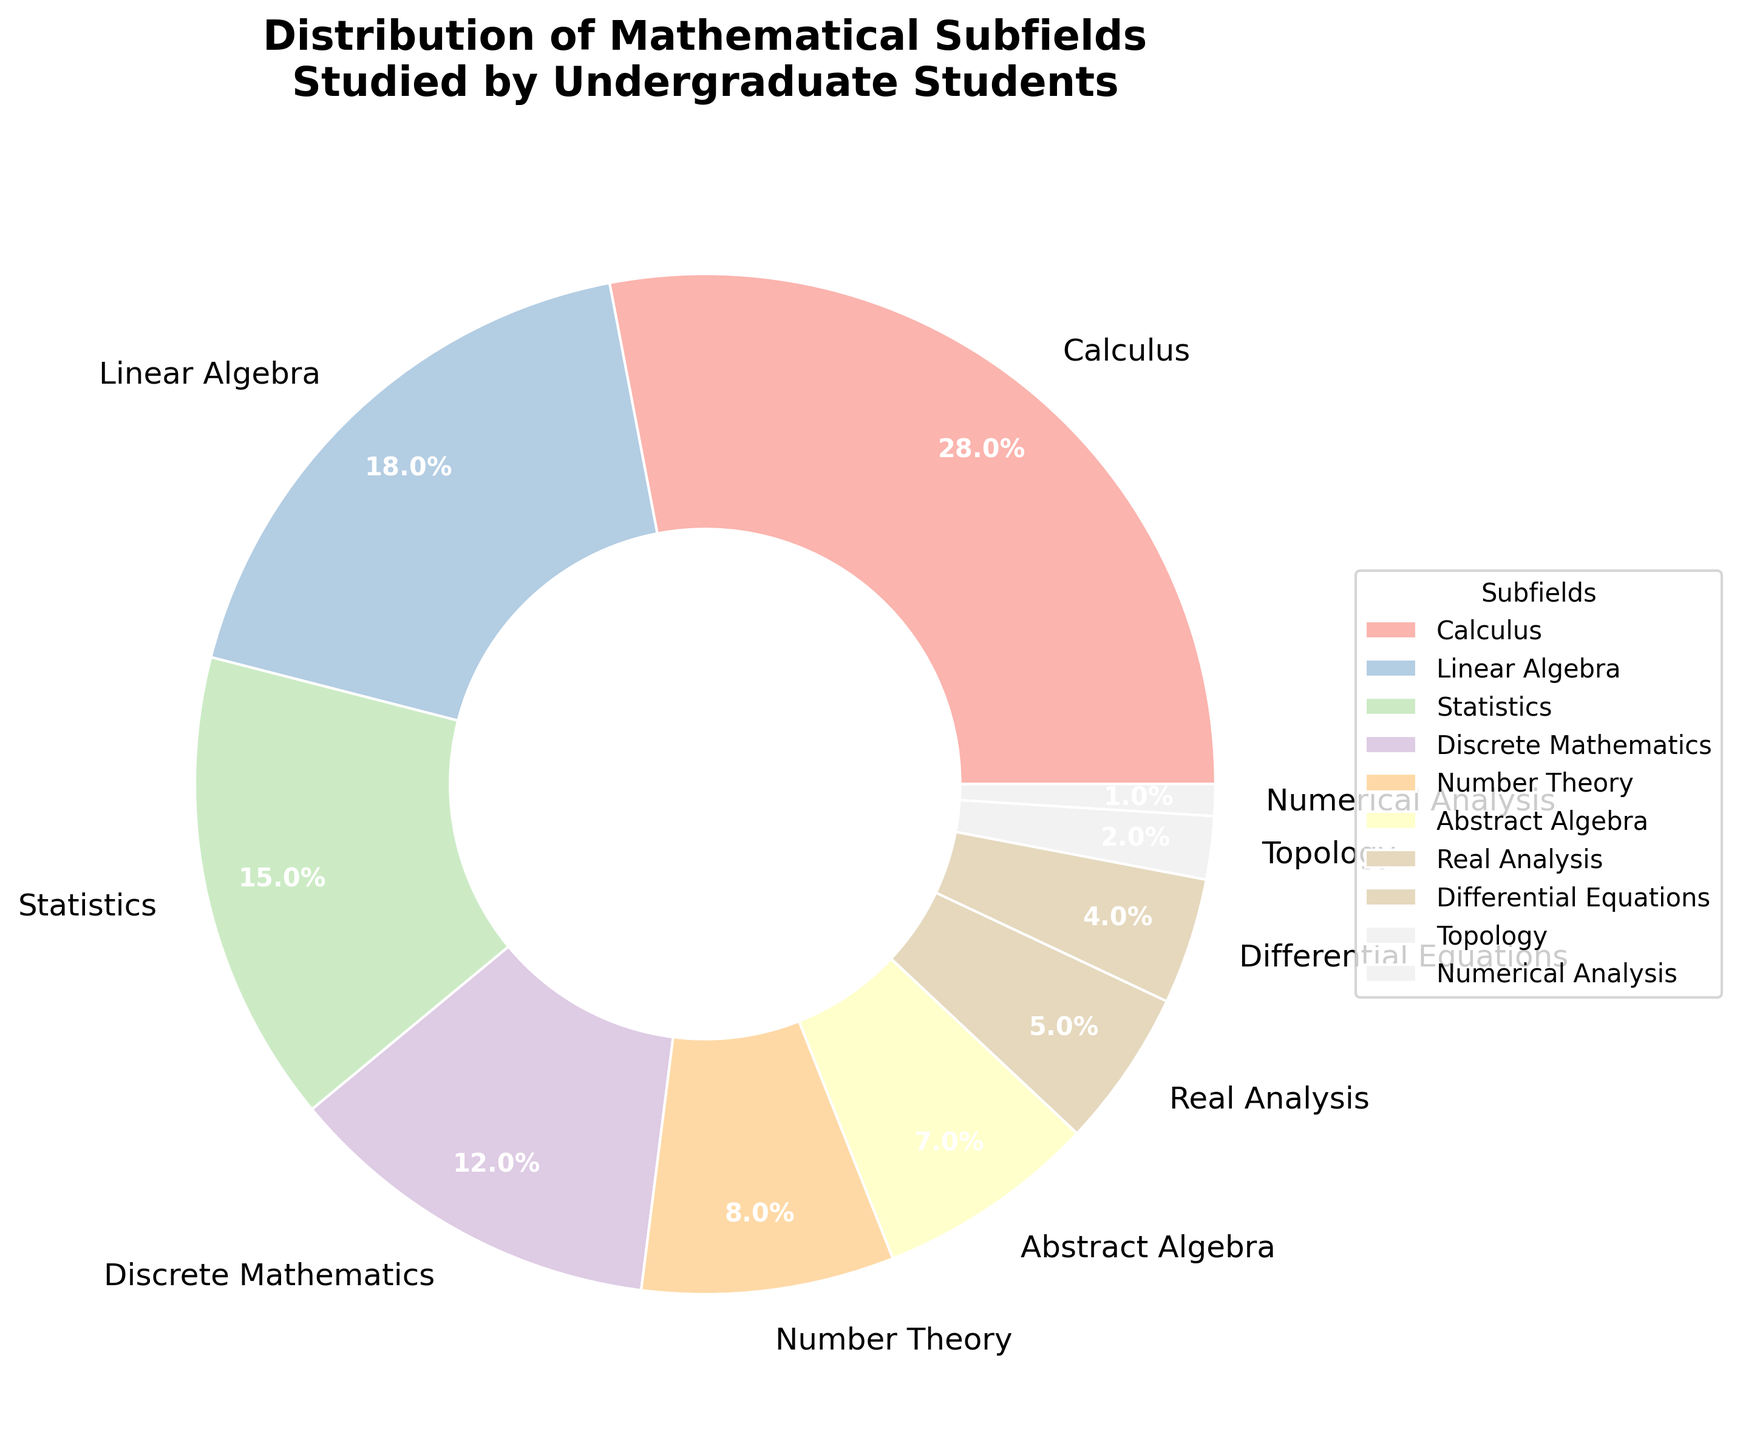what is the percentage of students studying Calculus? We can see that the slice labeled "Calculus" shows "28%" indicating that 28% of the students are studying Calculus.
Answer: 28% Which subfield has the lowest percentage of students studying it? The slice labeled "Numerical Analysis" has the smallest size and shows "1%", indicating that only 1% of the students study it.
Answer: Numerical Analysis How many subfields have more than 10% of students studying them? By observing the slices, we identify "Calculus (28%)", "Linear Algebra (18%)", "Statistics (15%)", and "Discrete Mathematics (12%)" as the subfields with percentages greater than 10%. Counting these slices, we get 4 subfields.
Answer: 4 Which subfields have a combined percentage that is less than Calculus alone? By adding the percentages of "Real Analysis (5%)", "Differential Equations (4%)", "Topology (2%)", and "Numerical Analysis (1%)", we get 5 + 4 + 2 + 1 = 12%, which is less than the 28% for Calculus alone.
Answer: Real Analysis, Differential Equations, Topology, Numerical Analysis What is the difference in the percentage of students studying Linear Algebra and Statistics? The percentage for Linear Algebra is 18% and for Statistics is 15%. The difference is calculated as 18% - 15% = 3%.
Answer: 3% What is the sum of the percentage of students studying Calculus and those studying Real Analysis? Calculus has 28% and Real Analysis has 5%, so the sum is 28 + 5 = 33%.
Answer: 33% Is there any subfield studied by exactly half of the percentage of students that study Calculus? Calculus is studied by 28% of the students. Half of 28% is 14%. None of the subfields listed have exactly 14%; thus, no subfield meets this criteria.
Answer: No Among the subfields with single-digit percentages, which subfield has the highest percentage? The single-digit percentages are "Number Theory (8%)", "Abstract Algebra (7%)", "Real Analysis (5%)", "Differential Equations (4%)", "Topology (2%)", and "Numerical Analysis (1%)". Among these, "Number Theory" with 8% is the highest.
Answer: Number Theory Which subfield, besides Calculus, contributes most significantly to the overall distribution? Excluding Calculus (28%), the next highest percentage is "Linear Algebra" with 18%, making it the most significant contributor after Calculus in the distribution.
Answer: Linear Algebra 